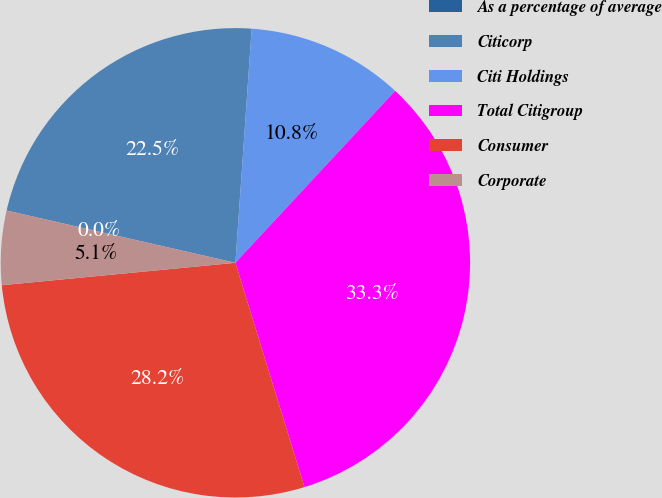Convert chart. <chart><loc_0><loc_0><loc_500><loc_500><pie_chart><fcel>As a percentage of average<fcel>Citicorp<fcel>Citi Holdings<fcel>Total Citigroup<fcel>Consumer<fcel>Corporate<nl><fcel>0.0%<fcel>22.53%<fcel>10.81%<fcel>33.33%<fcel>28.23%<fcel>5.1%<nl></chart> 